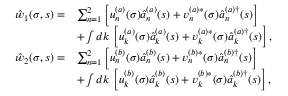<formula> <loc_0><loc_0><loc_500><loc_500>\begin{array} { r l } { { \hat { w } } _ { 1 } ( \sigma , s ) = } & { \sum _ { n = 1 } ^ { 2 } \left [ u _ { n } ^ { ( a ) } ( \sigma ) \hat { a } _ { n } ^ { ( a ) } ( s ) + v _ { n } ^ { ( a ) \ast } ( \sigma ) \hat { a } _ { n } ^ { ( a ) \dagger } ( s ) \right ] } \\ & { + \int d k \, \left [ u _ { k } ^ { ( a ) } ( \sigma ) \hat { a } _ { k } ^ { ( a ) } ( s ) + v _ { k } ^ { ( a ) \ast } ( \sigma ) \hat { a } _ { k } ^ { ( a ) \dagger } ( s ) \right ] , } \\ { { \hat { w } } _ { 2 } ( \sigma , s ) = } & { \sum _ { n = 1 } ^ { 2 } \left [ u _ { n } ^ { ( b ) } ( \sigma ) \hat { a } _ { n } ^ { ( b ) } ( s ) + v _ { n } ^ { ( b ) \ast } ( \sigma ) \hat { a } _ { n } ^ { ( b ) \dagger } ( s ) \right ] } \\ & { + \int d k \, \left [ u _ { k } ^ { ( b ) } ( \sigma ) \hat { a } _ { k } ^ { ( b ) } ( s ) + v _ { k } ^ { ( b ) \ast } ( \sigma ) \hat { a } _ { k } ^ { ( b ) \dagger } ( s ) \right ] , } \end{array}</formula> 